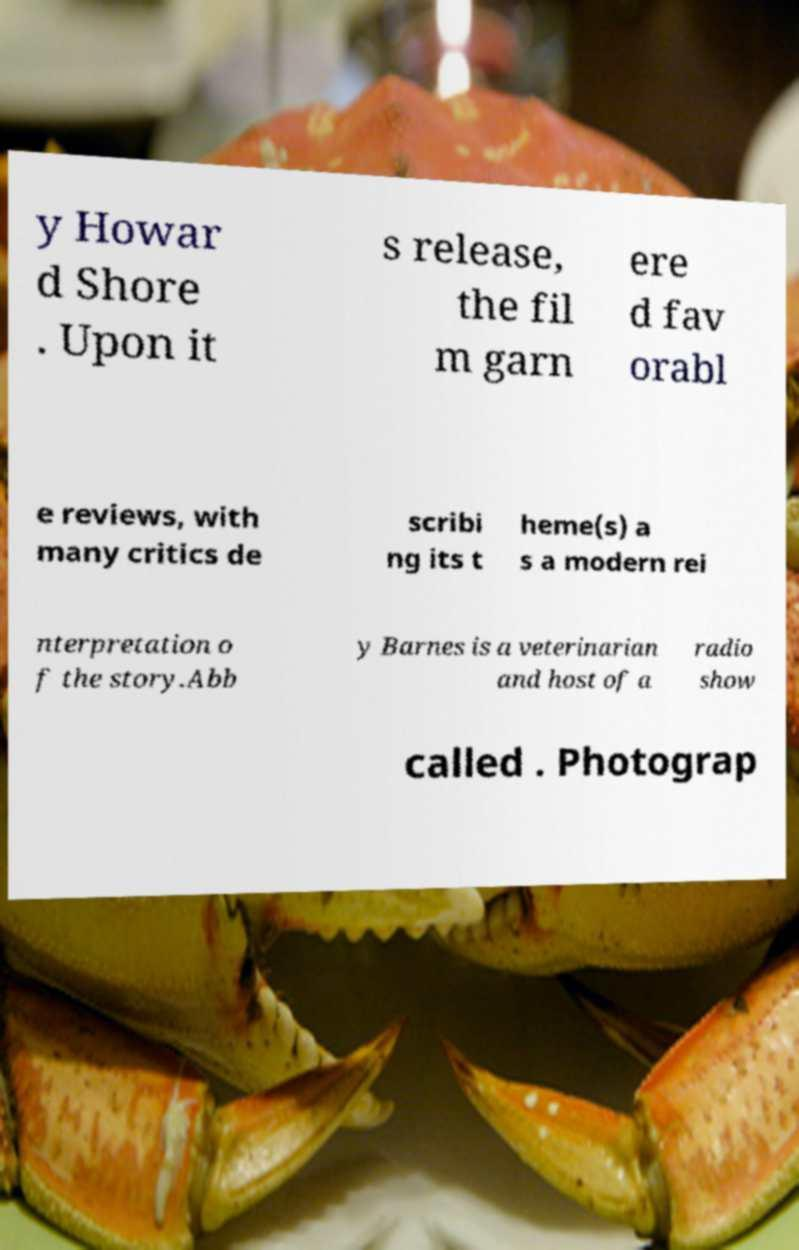Could you assist in decoding the text presented in this image and type it out clearly? y Howar d Shore . Upon it s release, the fil m garn ere d fav orabl e reviews, with many critics de scribi ng its t heme(s) a s a modern rei nterpretation o f the story.Abb y Barnes is a veterinarian and host of a radio show called . Photograp 